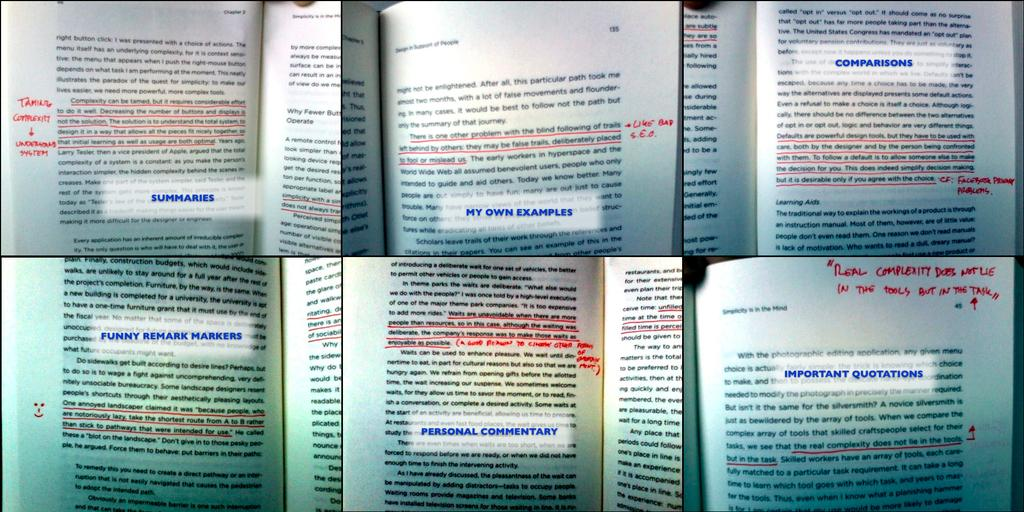<image>
Describe the image concisely. several open books that have labels such assummaries, my own examples, comparisons, etc 